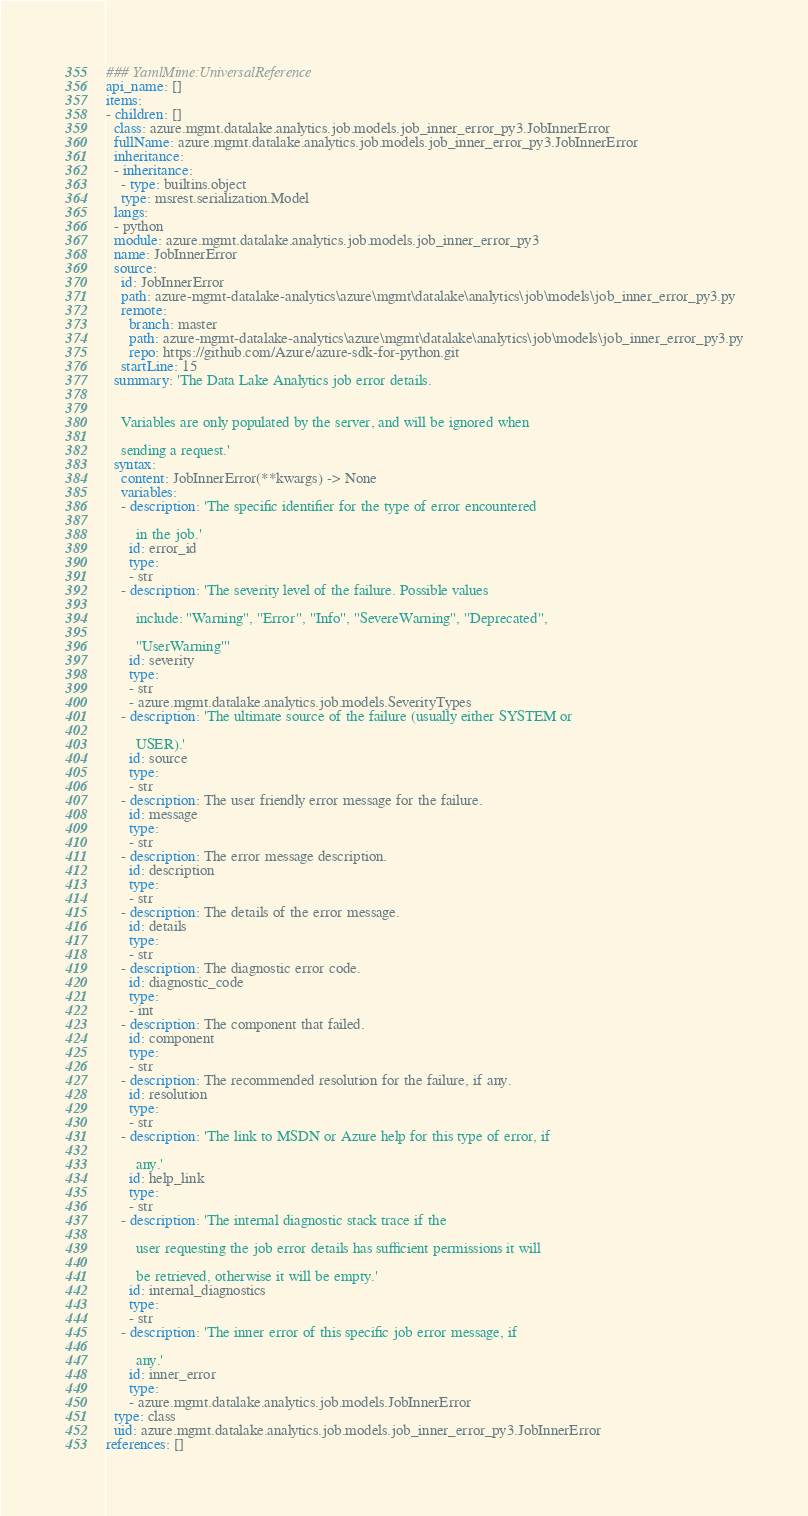Convert code to text. <code><loc_0><loc_0><loc_500><loc_500><_YAML_>### YamlMime:UniversalReference
api_name: []
items:
- children: []
  class: azure.mgmt.datalake.analytics.job.models.job_inner_error_py3.JobInnerError
  fullName: azure.mgmt.datalake.analytics.job.models.job_inner_error_py3.JobInnerError
  inheritance:
  - inheritance:
    - type: builtins.object
    type: msrest.serialization.Model
  langs:
  - python
  module: azure.mgmt.datalake.analytics.job.models.job_inner_error_py3
  name: JobInnerError
  source:
    id: JobInnerError
    path: azure-mgmt-datalake-analytics\azure\mgmt\datalake\analytics\job\models\job_inner_error_py3.py
    remote:
      branch: master
      path: azure-mgmt-datalake-analytics\azure\mgmt\datalake\analytics\job\models\job_inner_error_py3.py
      repo: https://github.com/Azure/azure-sdk-for-python.git
    startLine: 15
  summary: 'The Data Lake Analytics job error details.


    Variables are only populated by the server, and will be ignored when

    sending a request.'
  syntax:
    content: JobInnerError(**kwargs) -> None
    variables:
    - description: 'The specific identifier for the type of error encountered

        in the job.'
      id: error_id
      type:
      - str
    - description: 'The severity level of the failure. Possible values

        include: ''Warning'', ''Error'', ''Info'', ''SevereWarning'', ''Deprecated'',

        ''UserWarning'''
      id: severity
      type:
      - str
      - azure.mgmt.datalake.analytics.job.models.SeverityTypes
    - description: 'The ultimate source of the failure (usually either SYSTEM or

        USER).'
      id: source
      type:
      - str
    - description: The user friendly error message for the failure.
      id: message
      type:
      - str
    - description: The error message description.
      id: description
      type:
      - str
    - description: The details of the error message.
      id: details
      type:
      - str
    - description: The diagnostic error code.
      id: diagnostic_code
      type:
      - int
    - description: The component that failed.
      id: component
      type:
      - str
    - description: The recommended resolution for the failure, if any.
      id: resolution
      type:
      - str
    - description: 'The link to MSDN or Azure help for this type of error, if

        any.'
      id: help_link
      type:
      - str
    - description: 'The internal diagnostic stack trace if the

        user requesting the job error details has sufficient permissions it will

        be retrieved, otherwise it will be empty.'
      id: internal_diagnostics
      type:
      - str
    - description: 'The inner error of this specific job error message, if

        any.'
      id: inner_error
      type:
      - azure.mgmt.datalake.analytics.job.models.JobInnerError
  type: class
  uid: azure.mgmt.datalake.analytics.job.models.job_inner_error_py3.JobInnerError
references: []
</code> 